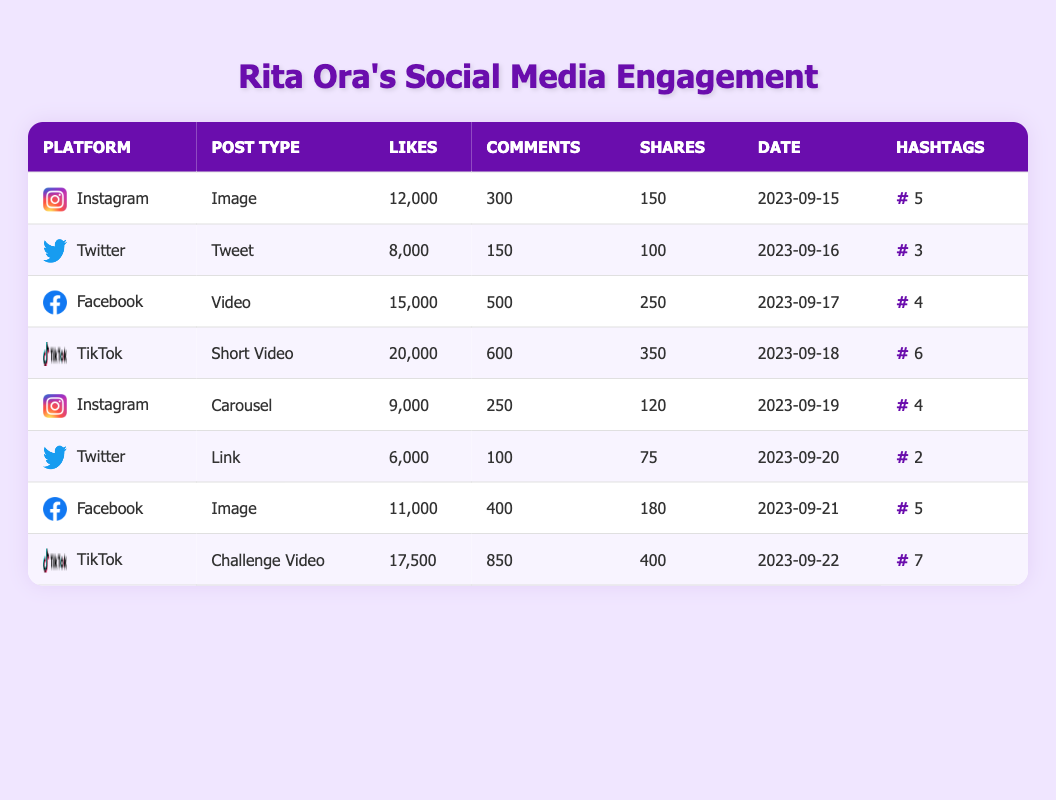What is the post type that received the most likes? By looking at the likes column, the post with the highest likes is "TikTok" with 20,000 likes for the post type "Short Video."
Answer: Short Video How many comments did the Facebook post on September 17 receive? The Facebook post on September 17, which is classified as a "Video," received 500 comments as shown in the comments column.
Answer: 500 Which platform has the highest total number of likes accumulated across all posts? To find the platform with the highest total likes, I sum up the likes for each platform: Instagram (12,000 + 9,000) = 21,000, Twitter (8,000 + 6,000) = 14,000, Facebook (15,000 + 11,000) = 26,000, and TikTok (20,000 + 17,500) = 37,500. TikTok has the highest total at 37,500 likes.
Answer: TikTok Did any posts with less than 150 comments receive more than 10,000 likes? Looking at the comments and likes, the "Instagram" post with 12,000 likes has 300 comments, and the "Twitter" post with 8,000 likes has 150 comments. All other posts with more than 10,000 likes had more than 150 comments. Therefore, none.
Answer: No What is the average number of shares across all posts? To find the average shares, I add the shares (150 + 100 + 250 + 350 + 120 + 75 + 180 + 400 = 1,625) and then divide by the number of posts (8). The average is 1,625 / 8 = 203.125, which rounds to 203.
Answer: 203 Which post type received the highest average number of likes? I compare the average likes by type: Image (12,000 + 11,000)/2 = 11,500, Video (15,000) = 15,000, Short Video (20,000) = 20,000, Carousel (9,000) = 9,000, and Challenge Video (17,500) = 17,500. The highest average is for Short Video at 20,000.
Answer: Short Video How many posts used more than 5 hashtags? Checking the hashtag usage column, only the "TikTok" post from September 18 and the "Challenge Video" on September 22 used more than 5 hashtags (6 and 7 respectively), making a total of 2 posts.
Answer: 2 Was the total number of comments across all posts greater than 3,000? Summing up the comments (300 + 150 + 500 + 600 + 250 + 100 + 400 + 850 = 3,250), it shows that 3,250 is greater than 3,000, so yes.
Answer: Yes 